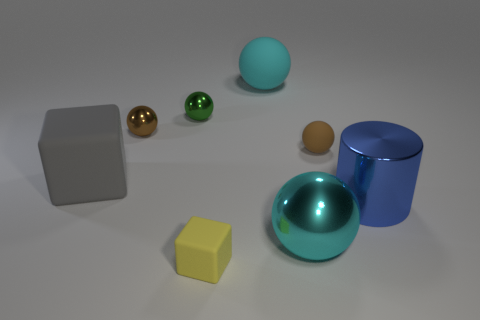Subtract all cyan balls. How many were subtracted if there are1cyan balls left? 1 Add 1 tiny matte cubes. How many objects exist? 9 Subtract all large cyan metallic balls. How many balls are left? 4 Subtract all gray cubes. How many cyan spheres are left? 2 Subtract 3 balls. How many balls are left? 2 Subtract all green balls. How many balls are left? 4 Subtract all cylinders. How many objects are left? 7 Subtract 2 cyan spheres. How many objects are left? 6 Subtract all purple spheres. Subtract all cyan cylinders. How many spheres are left? 5 Subtract all large purple metallic blocks. Subtract all large blue objects. How many objects are left? 7 